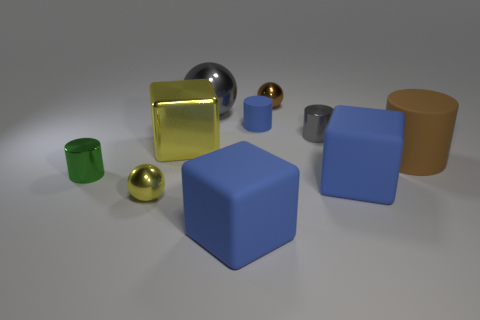The large matte cylinder is what color?
Your answer should be very brief. Brown. Is the shape of the small shiny object behind the large ball the same as  the big gray thing?
Ensure brevity in your answer.  Yes. What shape is the big blue matte thing left of the tiny sphere behind the big yellow cube in front of the brown metallic sphere?
Keep it short and to the point. Cube. There is a large block in front of the small yellow shiny object; what is its material?
Your answer should be very brief. Rubber. There is a rubber cylinder that is the same size as the yellow metallic sphere; what is its color?
Offer a terse response. Blue. What number of other objects are the same shape as the tiny brown object?
Keep it short and to the point. 2. Is the brown cylinder the same size as the metal block?
Your answer should be compact. Yes. Is the number of spheres that are in front of the small gray metal cylinder greater than the number of metal balls that are behind the tiny green cylinder?
Provide a short and direct response. No. How many other objects are the same size as the gray ball?
Your answer should be compact. 4. There is a small metallic cylinder right of the big shiny cube; is its color the same as the large metallic sphere?
Ensure brevity in your answer.  Yes. 